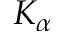<formula> <loc_0><loc_0><loc_500><loc_500>K _ { \alpha }</formula> 